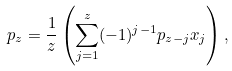<formula> <loc_0><loc_0><loc_500><loc_500>p _ { z } = \frac { 1 } { z } \left ( \sum _ { j = 1 } ^ { z } ( - 1 ) ^ { j - 1 } p _ { z - j } x _ { j } \right ) ,</formula> 